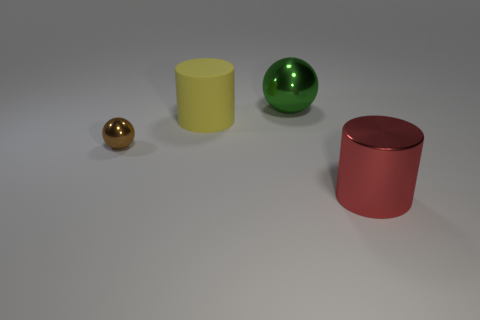Add 4 big purple shiny objects. How many objects exist? 8 Subtract all yellow cylinders. How many cylinders are left? 1 Subtract 1 balls. How many balls are left? 1 Add 3 yellow rubber objects. How many yellow rubber objects are left? 4 Add 4 cyan balls. How many cyan balls exist? 4 Subtract 0 gray balls. How many objects are left? 4 Subtract all yellow balls. Subtract all brown cubes. How many balls are left? 2 Subtract all purple spheres. How many blue cylinders are left? 0 Subtract all tiny objects. Subtract all big purple metallic spheres. How many objects are left? 3 